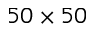Convert formula to latex. <formula><loc_0><loc_0><loc_500><loc_500>5 0 \times 5 0</formula> 